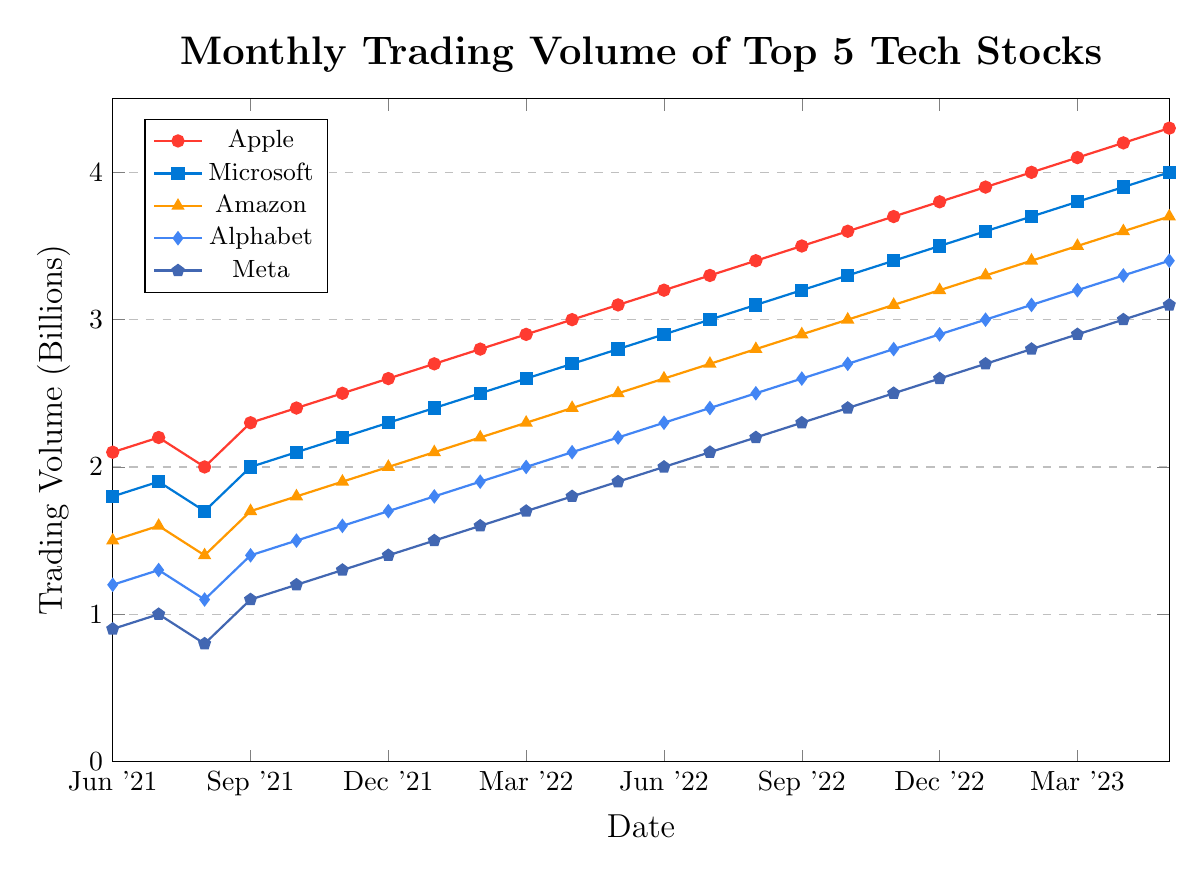Which stock has the highest trading volume in May 2023? Look for May 2023 (the last entry) and compare the values for all stocks. Apple has the highest trading volume at 4.3B.
Answer: Apple Which stock had consistently increasing volumes from June 2021 to May 2023? Verify each stock's data from June 2021 to May 2023 to see if the values always increase or stay the same. All stocks in the data (Apple, Microsoft, Amazon, Alphabet, and Meta) show a consistent increase each month.
Answer: All How much did Alphabet's trading volume increase from June 2021 to May 2023? Find the trading volumes for Alphabet in June 2021 and May 2023. Subtract June 2021 (1.2B) from May 2023 (3.4B). The increase is 3.4B - 1.2B = 2.2B.
Answer: 2.2B What is the difference between the trading volumes of Apple and Meta in June 2022? Compare Apple's 3.2B and Meta's 2.0B in June 2022. Subtract Meta's figure from Apple's: 3.2B - 2.0B = 1.2B.
Answer: 1.2B Which stock shows the most significant overall increase in trading volume from June 2021 to May 2023? Calculate the difference in trading volumes for each stock from June 2021 to May 2023 and compare them. Apple increased from 2.1B to 4.3B, which is the largest increase among the stocks.
Answer: Apple What is the average monthly trading volume of Amazon for the year 2022? Calculate the sum of Amazon's trading volumes from January 2022 to December 2022 and divide by 12. Sum is (2.1+2.2+2.3+2.4+2.5+2.6+2.7+2.8+2.9+3.0+3.1+3.2) = 31.2B. Average is 31.2B / 12 = 2.6B.
Answer: 2.6B In which month did Meta first surpass a trading volume of 2B? Check Meta's trading volumes for each month and identify the first month when the volume exceeds 2.0B. This happens in June 2022 (2.0B).
Answer: June 2022 Which two stocks had the closest trading volumes in October 2022? Compare trading volumes in October 2022 for all stocks. Amazon (3.0B) and Alphabet (2.7B) are the closest, with a difference of just 0.3B.
Answer: Amazon and Alphabet Did Apple's trading volume ever decrease from one month to the next in the given time frame? Review Apple's data from June 2021 to May 2023. All values are consistently increasing each month.
Answer: No Compare the trading volume of Microsoft and Alphabet in March 2022. Which is higher and by how much? Look at March 2022 values for Microsoft (2.6B) and Alphabet (2.0B). Subtract Alphabet's volume from Microsoft's: 2.6B - 2.0B = 0.6B. Microsoft has a higher trading volume by 0.6B.
Answer: Microsoft by 0.6B 